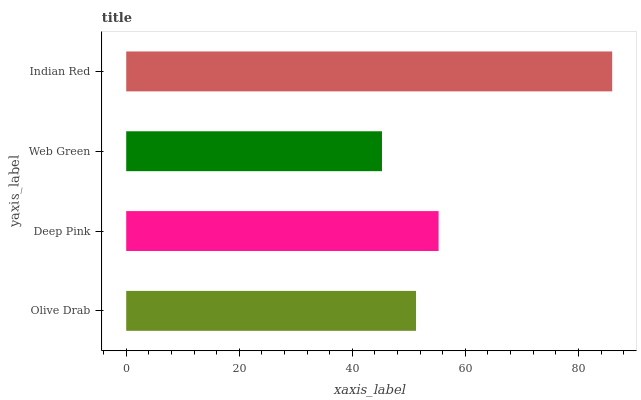Is Web Green the minimum?
Answer yes or no. Yes. Is Indian Red the maximum?
Answer yes or no. Yes. Is Deep Pink the minimum?
Answer yes or no. No. Is Deep Pink the maximum?
Answer yes or no. No. Is Deep Pink greater than Olive Drab?
Answer yes or no. Yes. Is Olive Drab less than Deep Pink?
Answer yes or no. Yes. Is Olive Drab greater than Deep Pink?
Answer yes or no. No. Is Deep Pink less than Olive Drab?
Answer yes or no. No. Is Deep Pink the high median?
Answer yes or no. Yes. Is Olive Drab the low median?
Answer yes or no. Yes. Is Indian Red the high median?
Answer yes or no. No. Is Web Green the low median?
Answer yes or no. No. 